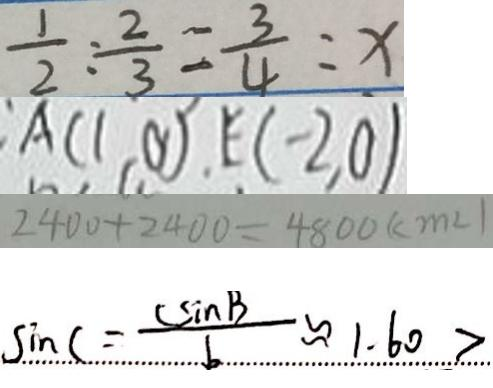<formula> <loc_0><loc_0><loc_500><loc_500>\frac { 1 } { 2 } : \frac { 2 } { 3 } = \frac { 3 } { 4 } : x 
 A ( 1 , 0 ) , E ( - 2 , 0 ) 
 2 4 0 0 + 2 4 0 0 = 4 8 0 0 ( c m ^ { 2 } ) 
 \sin C = \frac { c \sin B } { b } \approx 1 . 6 0 ></formula> 